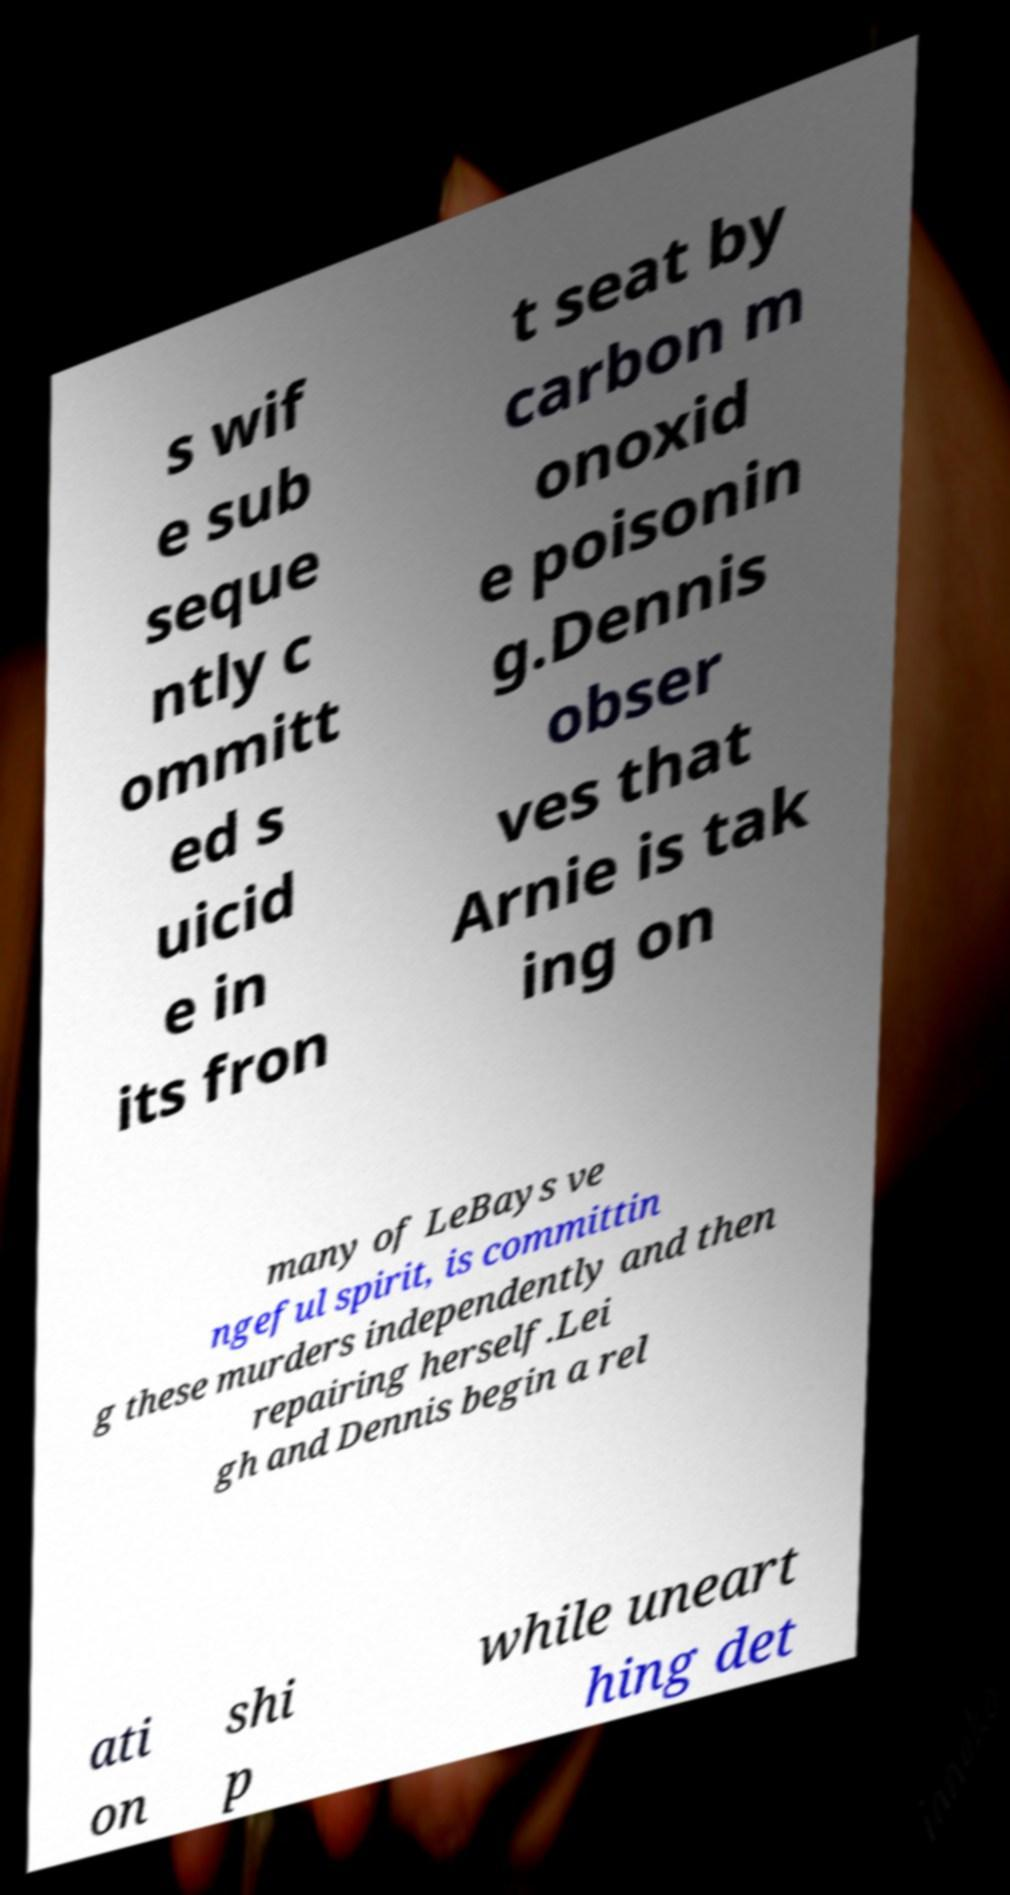Can you accurately transcribe the text from the provided image for me? s wif e sub seque ntly c ommitt ed s uicid e in its fron t seat by carbon m onoxid e poisonin g.Dennis obser ves that Arnie is tak ing on many of LeBays ve ngeful spirit, is committin g these murders independently and then repairing herself.Lei gh and Dennis begin a rel ati on shi p while uneart hing det 